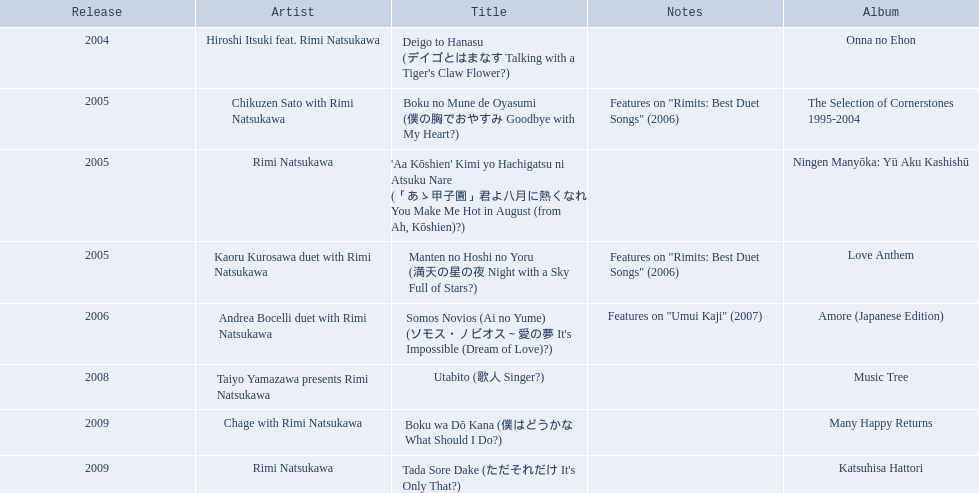When did onna no ehon come out? 2004. When did the selection of cornerstones 1995-2004 come out? 2005. What came out in 2008? Music Tree. 